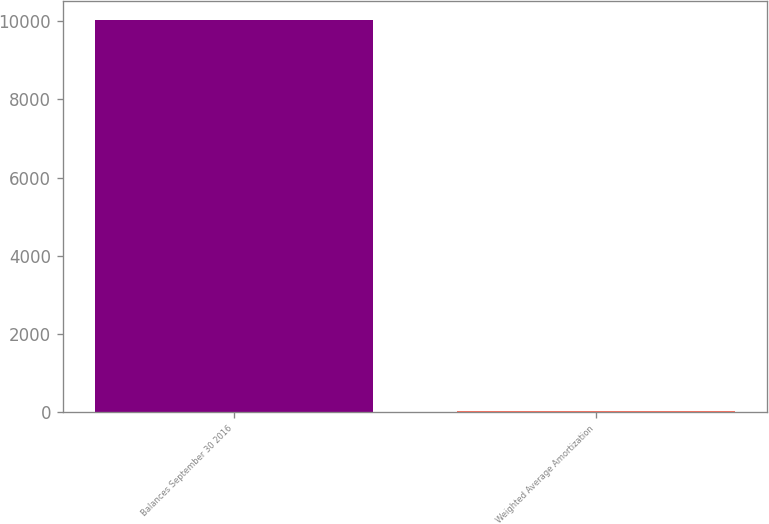<chart> <loc_0><loc_0><loc_500><loc_500><bar_chart><fcel>Balances September 30 2016<fcel>Weighted Average Amortization<nl><fcel>10027<fcel>25<nl></chart> 